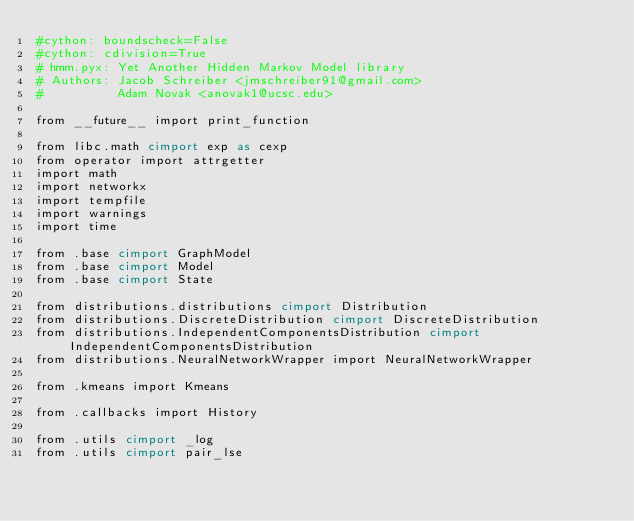Convert code to text. <code><loc_0><loc_0><loc_500><loc_500><_Cython_>#cython: boundscheck=False
#cython: cdivision=True
# hmm.pyx: Yet Another Hidden Markov Model library
# Authors: Jacob Schreiber <jmschreiber91@gmail.com>
#          Adam Novak <anovak1@ucsc.edu>

from __future__ import print_function

from libc.math cimport exp as cexp
from operator import attrgetter
import math
import networkx
import tempfile
import warnings
import time

from .base cimport GraphModel
from .base cimport Model
from .base cimport State

from distributions.distributions cimport Distribution
from distributions.DiscreteDistribution cimport DiscreteDistribution
from distributions.IndependentComponentsDistribution cimport IndependentComponentsDistribution
from distributions.NeuralNetworkWrapper import NeuralNetworkWrapper

from .kmeans import Kmeans

from .callbacks import History

from .utils cimport _log
from .utils cimport pair_lse</code> 